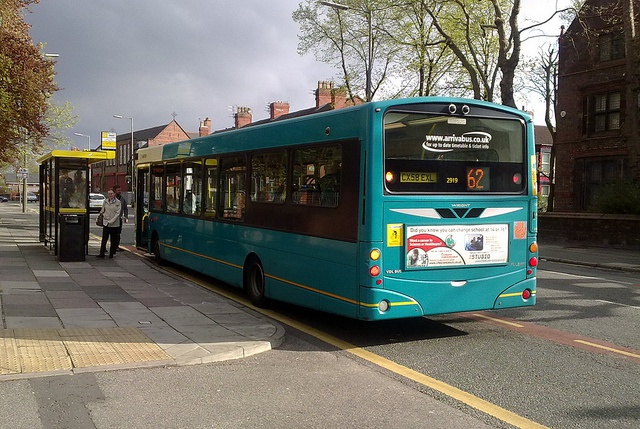Describe the objects in this image and their specific colors. I can see bus in olive, black, teal, and white tones, people in olive, black, and gray tones, car in olive, black, gray, darkgray, and lightgray tones, people in olive, black, maroon, gray, and darkgray tones, and people in olive, black, and gray tones in this image. 